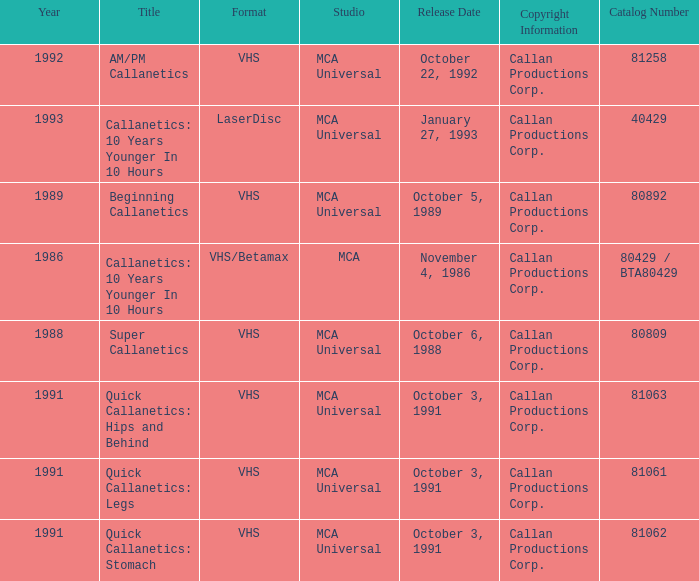Parse the full table. {'header': ['Year', 'Title', 'Format', 'Studio', 'Release Date', 'Copyright Information', 'Catalog Number'], 'rows': [['1992', 'AM/PM Callanetics', 'VHS', 'MCA Universal', 'October 22, 1992', 'Callan Productions Corp.', '81258'], ['1993', 'Callanetics: 10 Years Younger In 10 Hours', 'LaserDisc', 'MCA Universal', 'January 27, 1993', 'Callan Productions Corp.', '40429'], ['1989', 'Beginning Callanetics', 'VHS', 'MCA Universal', 'October 5, 1989', 'Callan Productions Corp.', '80892'], ['1986', 'Callanetics: 10 Years Younger In 10 Hours', 'VHS/Betamax', 'MCA', 'November 4, 1986', 'Callan Productions Corp.', '80429 / BTA80429'], ['1988', 'Super Callanetics', 'VHS', 'MCA Universal', 'October 6, 1988', 'Callan Productions Corp.', '80809'], ['1991', 'Quick Callanetics: Hips and Behind', 'VHS', 'MCA Universal', 'October 3, 1991', 'Callan Productions Corp.', '81063'], ['1991', 'Quick Callanetics: Legs', 'VHS', 'MCA Universal', 'October 3, 1991', 'Callan Productions Corp.', '81061'], ['1991', 'Quick Callanetics: Stomach', 'VHS', 'MCA Universal', 'October 3, 1991', 'Callan Productions Corp.', '81062']]} Name the catalog number for am/pm callanetics 81258.0. 